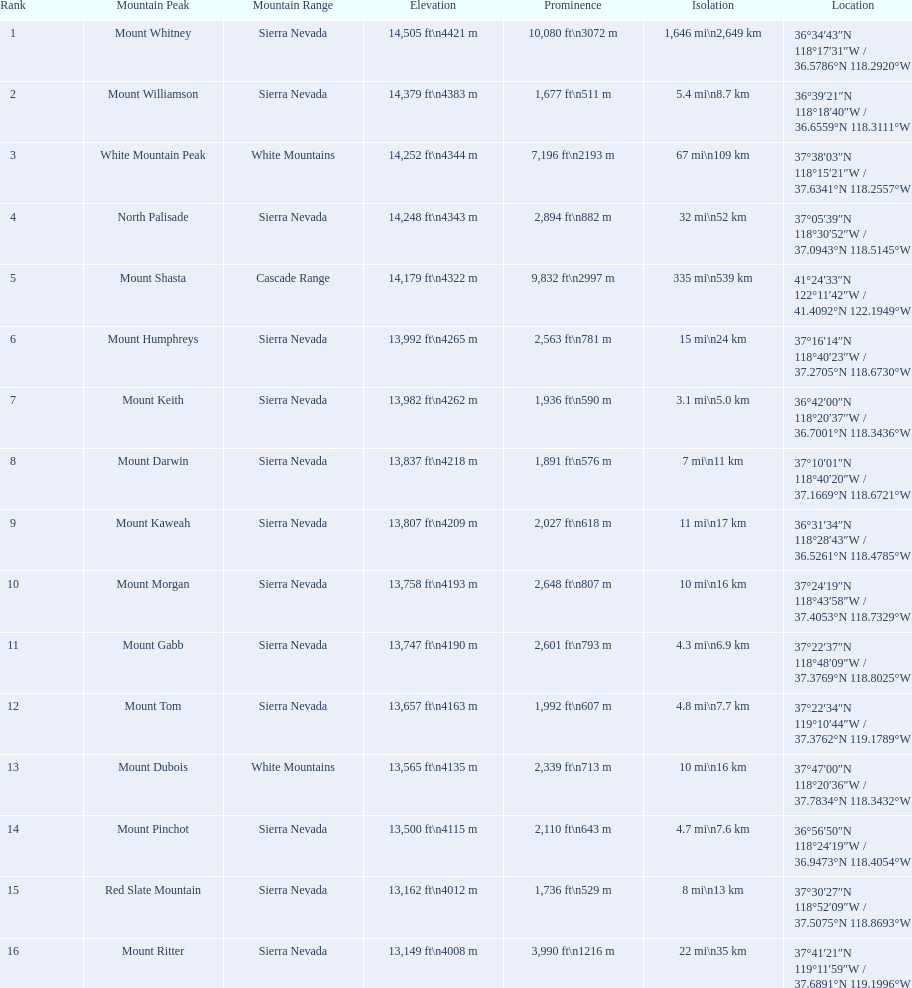What is the entire elevation (in ft) of mount whitney? 14,505 ft. 